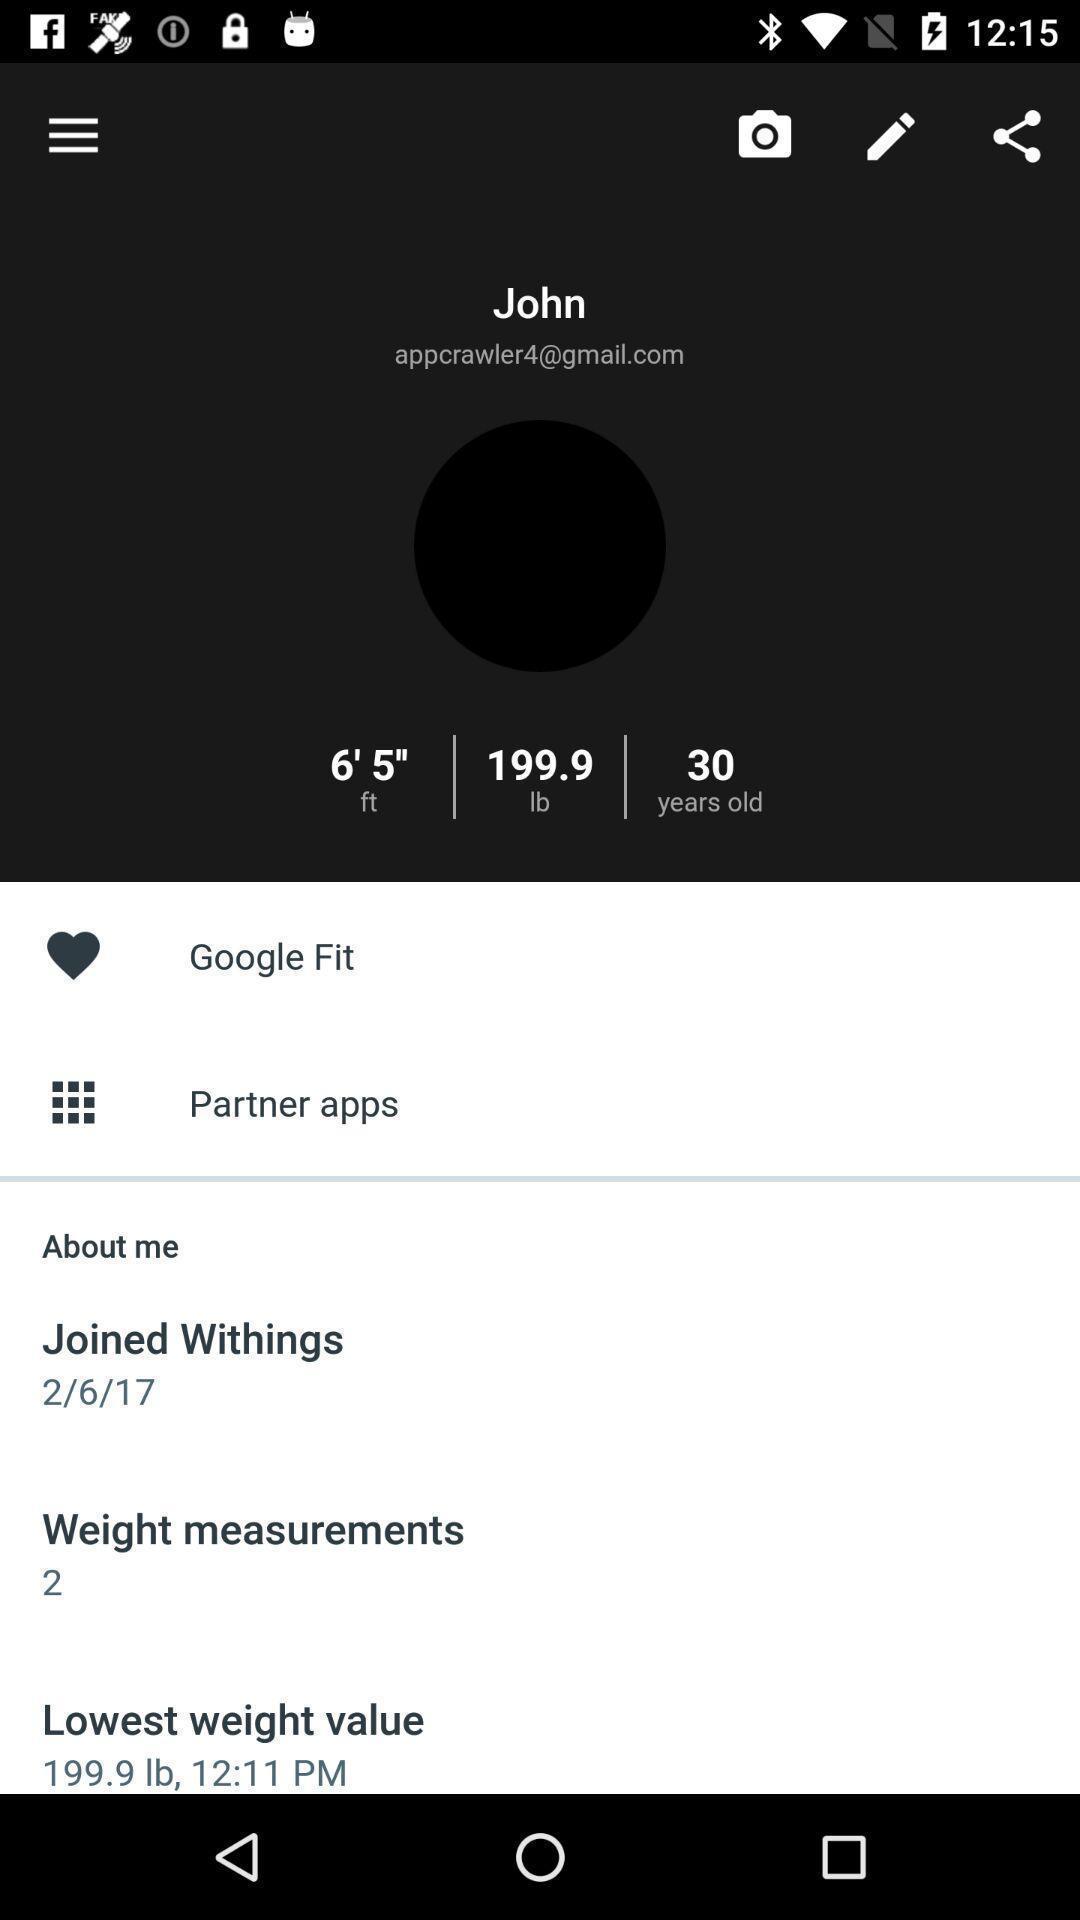Describe the content in this image. Screen displaying multiple options in a health tracking application. 